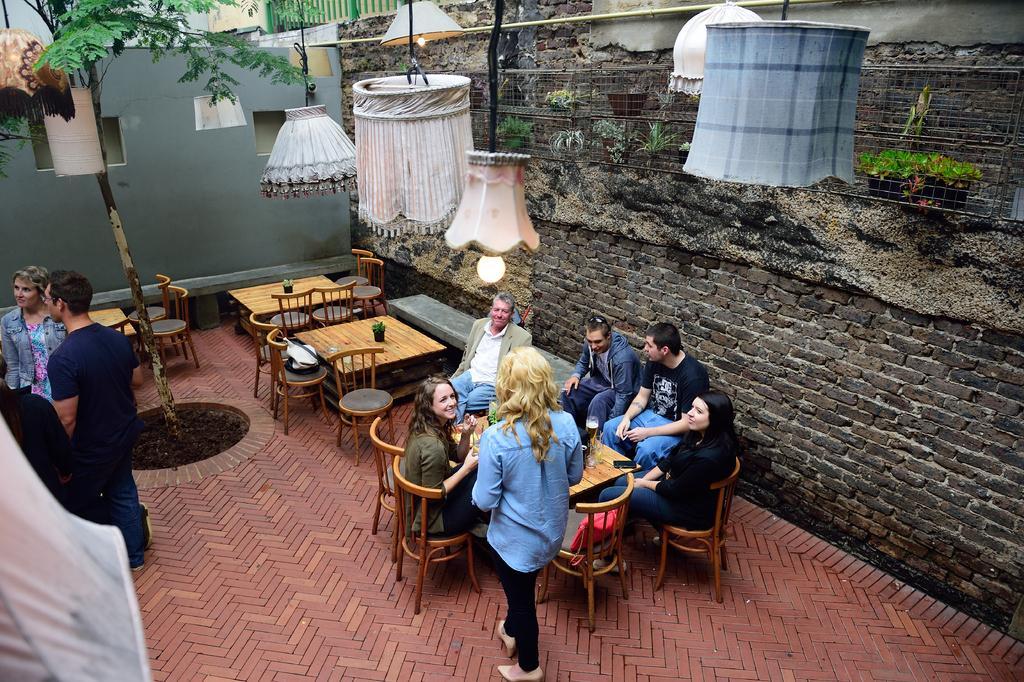Could you give a brief overview of what you see in this image? This picture is of outside. On the right there are group of persons sitting on the chairs and there is a glass placed on the top of the table and we can see a woman standing. On the left we can see two persons standing. In the background we can see a wall, a window, lamps, tree, tables and chairs. 